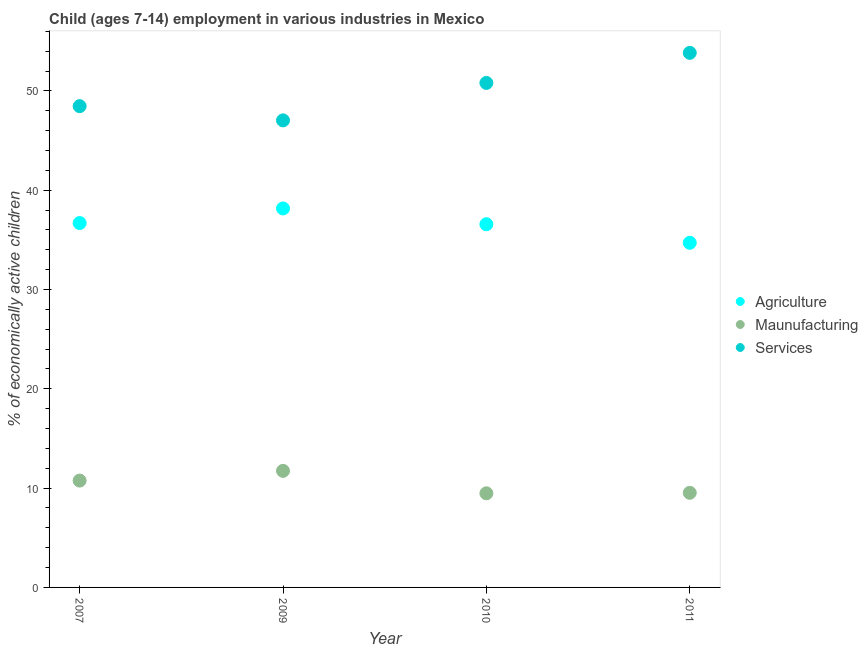Is the number of dotlines equal to the number of legend labels?
Provide a succinct answer. Yes. What is the percentage of economically active children in services in 2007?
Ensure brevity in your answer.  48.47. Across all years, what is the maximum percentage of economically active children in services?
Make the answer very short. 53.84. Across all years, what is the minimum percentage of economically active children in services?
Offer a terse response. 47.04. What is the total percentage of economically active children in services in the graph?
Your answer should be compact. 200.16. What is the difference between the percentage of economically active children in manufacturing in 2007 and that in 2011?
Provide a short and direct response. 1.23. What is the difference between the percentage of economically active children in services in 2011 and the percentage of economically active children in agriculture in 2009?
Provide a succinct answer. 15.67. What is the average percentage of economically active children in services per year?
Provide a succinct answer. 50.04. In the year 2011, what is the difference between the percentage of economically active children in services and percentage of economically active children in manufacturing?
Offer a very short reply. 44.31. In how many years, is the percentage of economically active children in manufacturing greater than 54 %?
Provide a short and direct response. 0. What is the ratio of the percentage of economically active children in services in 2007 to that in 2010?
Offer a terse response. 0.95. Is the percentage of economically active children in services in 2009 less than that in 2011?
Keep it short and to the point. Yes. What is the difference between the highest and the second highest percentage of economically active children in agriculture?
Make the answer very short. 1.47. What is the difference between the highest and the lowest percentage of economically active children in manufacturing?
Give a very brief answer. 2.26. In how many years, is the percentage of economically active children in services greater than the average percentage of economically active children in services taken over all years?
Ensure brevity in your answer.  2. Is it the case that in every year, the sum of the percentage of economically active children in agriculture and percentage of economically active children in manufacturing is greater than the percentage of economically active children in services?
Ensure brevity in your answer.  No. Does the percentage of economically active children in agriculture monotonically increase over the years?
Your answer should be compact. No. What is the difference between two consecutive major ticks on the Y-axis?
Keep it short and to the point. 10. Are the values on the major ticks of Y-axis written in scientific E-notation?
Give a very brief answer. No. Does the graph contain any zero values?
Provide a short and direct response. No. Does the graph contain grids?
Make the answer very short. No. Where does the legend appear in the graph?
Your response must be concise. Center right. What is the title of the graph?
Make the answer very short. Child (ages 7-14) employment in various industries in Mexico. Does "Capital account" appear as one of the legend labels in the graph?
Provide a succinct answer. No. What is the label or title of the Y-axis?
Provide a short and direct response. % of economically active children. What is the % of economically active children of Agriculture in 2007?
Keep it short and to the point. 36.7. What is the % of economically active children in Maunufacturing in 2007?
Ensure brevity in your answer.  10.76. What is the % of economically active children of Services in 2007?
Make the answer very short. 48.47. What is the % of economically active children in Agriculture in 2009?
Give a very brief answer. 38.17. What is the % of economically active children of Maunufacturing in 2009?
Provide a succinct answer. 11.74. What is the % of economically active children in Services in 2009?
Offer a very short reply. 47.04. What is the % of economically active children of Agriculture in 2010?
Provide a succinct answer. 36.58. What is the % of economically active children in Maunufacturing in 2010?
Your response must be concise. 9.48. What is the % of economically active children in Services in 2010?
Give a very brief answer. 50.81. What is the % of economically active children in Agriculture in 2011?
Offer a terse response. 34.71. What is the % of economically active children in Maunufacturing in 2011?
Your response must be concise. 9.53. What is the % of economically active children of Services in 2011?
Your answer should be compact. 53.84. Across all years, what is the maximum % of economically active children of Agriculture?
Your answer should be very brief. 38.17. Across all years, what is the maximum % of economically active children in Maunufacturing?
Ensure brevity in your answer.  11.74. Across all years, what is the maximum % of economically active children in Services?
Make the answer very short. 53.84. Across all years, what is the minimum % of economically active children of Agriculture?
Ensure brevity in your answer.  34.71. Across all years, what is the minimum % of economically active children of Maunufacturing?
Your answer should be compact. 9.48. Across all years, what is the minimum % of economically active children of Services?
Your answer should be very brief. 47.04. What is the total % of economically active children of Agriculture in the graph?
Your answer should be compact. 146.16. What is the total % of economically active children of Maunufacturing in the graph?
Make the answer very short. 41.51. What is the total % of economically active children of Services in the graph?
Offer a very short reply. 200.16. What is the difference between the % of economically active children in Agriculture in 2007 and that in 2009?
Your answer should be compact. -1.47. What is the difference between the % of economically active children in Maunufacturing in 2007 and that in 2009?
Give a very brief answer. -0.98. What is the difference between the % of economically active children in Services in 2007 and that in 2009?
Provide a succinct answer. 1.43. What is the difference between the % of economically active children of Agriculture in 2007 and that in 2010?
Provide a succinct answer. 0.12. What is the difference between the % of economically active children in Maunufacturing in 2007 and that in 2010?
Provide a succinct answer. 1.28. What is the difference between the % of economically active children of Services in 2007 and that in 2010?
Provide a short and direct response. -2.34. What is the difference between the % of economically active children of Agriculture in 2007 and that in 2011?
Your response must be concise. 1.99. What is the difference between the % of economically active children of Maunufacturing in 2007 and that in 2011?
Provide a succinct answer. 1.23. What is the difference between the % of economically active children of Services in 2007 and that in 2011?
Your answer should be compact. -5.37. What is the difference between the % of economically active children of Agriculture in 2009 and that in 2010?
Offer a very short reply. 1.59. What is the difference between the % of economically active children of Maunufacturing in 2009 and that in 2010?
Your answer should be very brief. 2.26. What is the difference between the % of economically active children in Services in 2009 and that in 2010?
Your answer should be very brief. -3.77. What is the difference between the % of economically active children in Agriculture in 2009 and that in 2011?
Your answer should be compact. 3.46. What is the difference between the % of economically active children in Maunufacturing in 2009 and that in 2011?
Keep it short and to the point. 2.21. What is the difference between the % of economically active children in Services in 2009 and that in 2011?
Make the answer very short. -6.8. What is the difference between the % of economically active children of Agriculture in 2010 and that in 2011?
Your response must be concise. 1.87. What is the difference between the % of economically active children of Services in 2010 and that in 2011?
Offer a very short reply. -3.03. What is the difference between the % of economically active children of Agriculture in 2007 and the % of economically active children of Maunufacturing in 2009?
Give a very brief answer. 24.96. What is the difference between the % of economically active children of Agriculture in 2007 and the % of economically active children of Services in 2009?
Give a very brief answer. -10.34. What is the difference between the % of economically active children in Maunufacturing in 2007 and the % of economically active children in Services in 2009?
Your answer should be compact. -36.28. What is the difference between the % of economically active children in Agriculture in 2007 and the % of economically active children in Maunufacturing in 2010?
Keep it short and to the point. 27.22. What is the difference between the % of economically active children in Agriculture in 2007 and the % of economically active children in Services in 2010?
Your answer should be compact. -14.11. What is the difference between the % of economically active children in Maunufacturing in 2007 and the % of economically active children in Services in 2010?
Your answer should be very brief. -40.05. What is the difference between the % of economically active children of Agriculture in 2007 and the % of economically active children of Maunufacturing in 2011?
Provide a short and direct response. 27.17. What is the difference between the % of economically active children of Agriculture in 2007 and the % of economically active children of Services in 2011?
Your answer should be compact. -17.14. What is the difference between the % of economically active children of Maunufacturing in 2007 and the % of economically active children of Services in 2011?
Your answer should be very brief. -43.08. What is the difference between the % of economically active children of Agriculture in 2009 and the % of economically active children of Maunufacturing in 2010?
Keep it short and to the point. 28.69. What is the difference between the % of economically active children in Agriculture in 2009 and the % of economically active children in Services in 2010?
Offer a terse response. -12.64. What is the difference between the % of economically active children in Maunufacturing in 2009 and the % of economically active children in Services in 2010?
Offer a terse response. -39.07. What is the difference between the % of economically active children of Agriculture in 2009 and the % of economically active children of Maunufacturing in 2011?
Your answer should be compact. 28.64. What is the difference between the % of economically active children in Agriculture in 2009 and the % of economically active children in Services in 2011?
Keep it short and to the point. -15.67. What is the difference between the % of economically active children of Maunufacturing in 2009 and the % of economically active children of Services in 2011?
Offer a very short reply. -42.1. What is the difference between the % of economically active children of Agriculture in 2010 and the % of economically active children of Maunufacturing in 2011?
Offer a very short reply. 27.05. What is the difference between the % of economically active children of Agriculture in 2010 and the % of economically active children of Services in 2011?
Offer a very short reply. -17.26. What is the difference between the % of economically active children of Maunufacturing in 2010 and the % of economically active children of Services in 2011?
Provide a succinct answer. -44.36. What is the average % of economically active children of Agriculture per year?
Your answer should be very brief. 36.54. What is the average % of economically active children in Maunufacturing per year?
Provide a short and direct response. 10.38. What is the average % of economically active children in Services per year?
Make the answer very short. 50.04. In the year 2007, what is the difference between the % of economically active children of Agriculture and % of economically active children of Maunufacturing?
Offer a terse response. 25.94. In the year 2007, what is the difference between the % of economically active children of Agriculture and % of economically active children of Services?
Provide a short and direct response. -11.77. In the year 2007, what is the difference between the % of economically active children of Maunufacturing and % of economically active children of Services?
Provide a succinct answer. -37.71. In the year 2009, what is the difference between the % of economically active children of Agriculture and % of economically active children of Maunufacturing?
Your answer should be very brief. 26.43. In the year 2009, what is the difference between the % of economically active children of Agriculture and % of economically active children of Services?
Provide a short and direct response. -8.87. In the year 2009, what is the difference between the % of economically active children of Maunufacturing and % of economically active children of Services?
Offer a terse response. -35.3. In the year 2010, what is the difference between the % of economically active children of Agriculture and % of economically active children of Maunufacturing?
Keep it short and to the point. 27.1. In the year 2010, what is the difference between the % of economically active children in Agriculture and % of economically active children in Services?
Ensure brevity in your answer.  -14.23. In the year 2010, what is the difference between the % of economically active children of Maunufacturing and % of economically active children of Services?
Offer a terse response. -41.33. In the year 2011, what is the difference between the % of economically active children in Agriculture and % of economically active children in Maunufacturing?
Offer a very short reply. 25.18. In the year 2011, what is the difference between the % of economically active children in Agriculture and % of economically active children in Services?
Your answer should be compact. -19.13. In the year 2011, what is the difference between the % of economically active children of Maunufacturing and % of economically active children of Services?
Your answer should be compact. -44.31. What is the ratio of the % of economically active children of Agriculture in 2007 to that in 2009?
Your response must be concise. 0.96. What is the ratio of the % of economically active children in Maunufacturing in 2007 to that in 2009?
Make the answer very short. 0.92. What is the ratio of the % of economically active children in Services in 2007 to that in 2009?
Give a very brief answer. 1.03. What is the ratio of the % of economically active children of Agriculture in 2007 to that in 2010?
Give a very brief answer. 1. What is the ratio of the % of economically active children in Maunufacturing in 2007 to that in 2010?
Provide a succinct answer. 1.14. What is the ratio of the % of economically active children of Services in 2007 to that in 2010?
Your answer should be very brief. 0.95. What is the ratio of the % of economically active children in Agriculture in 2007 to that in 2011?
Keep it short and to the point. 1.06. What is the ratio of the % of economically active children of Maunufacturing in 2007 to that in 2011?
Provide a succinct answer. 1.13. What is the ratio of the % of economically active children in Services in 2007 to that in 2011?
Offer a terse response. 0.9. What is the ratio of the % of economically active children in Agriculture in 2009 to that in 2010?
Offer a very short reply. 1.04. What is the ratio of the % of economically active children of Maunufacturing in 2009 to that in 2010?
Make the answer very short. 1.24. What is the ratio of the % of economically active children of Services in 2009 to that in 2010?
Offer a terse response. 0.93. What is the ratio of the % of economically active children of Agriculture in 2009 to that in 2011?
Offer a terse response. 1.1. What is the ratio of the % of economically active children in Maunufacturing in 2009 to that in 2011?
Offer a very short reply. 1.23. What is the ratio of the % of economically active children of Services in 2009 to that in 2011?
Make the answer very short. 0.87. What is the ratio of the % of economically active children of Agriculture in 2010 to that in 2011?
Offer a very short reply. 1.05. What is the ratio of the % of economically active children in Maunufacturing in 2010 to that in 2011?
Provide a short and direct response. 0.99. What is the ratio of the % of economically active children of Services in 2010 to that in 2011?
Give a very brief answer. 0.94. What is the difference between the highest and the second highest % of economically active children in Agriculture?
Your answer should be very brief. 1.47. What is the difference between the highest and the second highest % of economically active children of Maunufacturing?
Your answer should be very brief. 0.98. What is the difference between the highest and the second highest % of economically active children of Services?
Your response must be concise. 3.03. What is the difference between the highest and the lowest % of economically active children of Agriculture?
Your answer should be compact. 3.46. What is the difference between the highest and the lowest % of economically active children of Maunufacturing?
Provide a short and direct response. 2.26. What is the difference between the highest and the lowest % of economically active children of Services?
Offer a terse response. 6.8. 